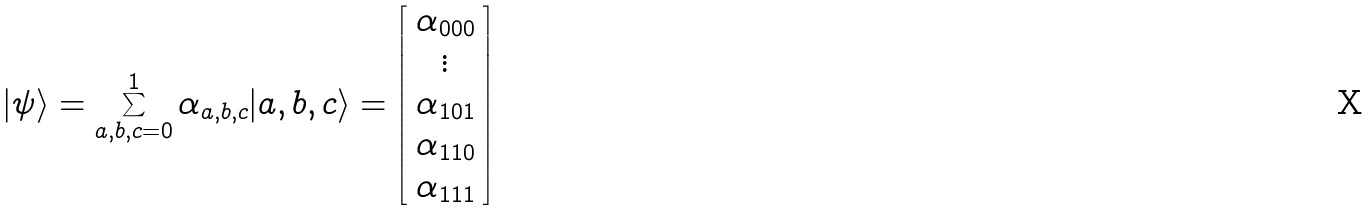<formula> <loc_0><loc_0><loc_500><loc_500>| \psi \rangle = \sum _ { a , b , c = 0 } ^ { 1 } \alpha _ { a , b , c } | a , b , c \rangle = \left [ \begin{array} { c } \alpha _ { 0 0 0 } \\ \vdots \\ \alpha _ { 1 0 1 } \\ \alpha _ { 1 1 0 } \\ \alpha _ { 1 1 1 } \end{array} \right ]</formula> 